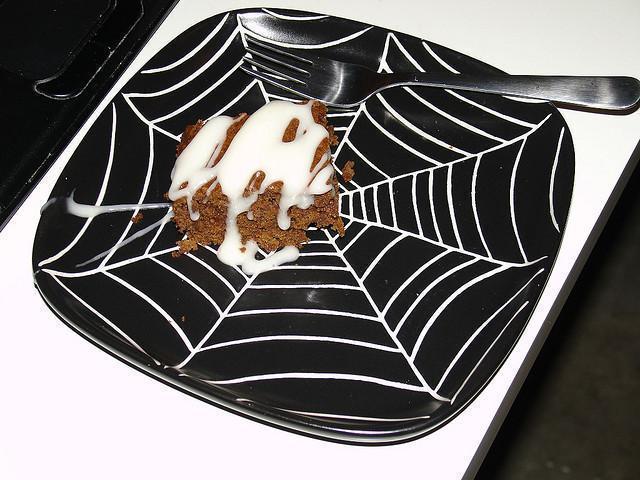What design is painted onto the plate?
From the following four choices, select the correct answer to address the question.
Options: Crisscross, checkers, chevron, spider web. Spider web. 